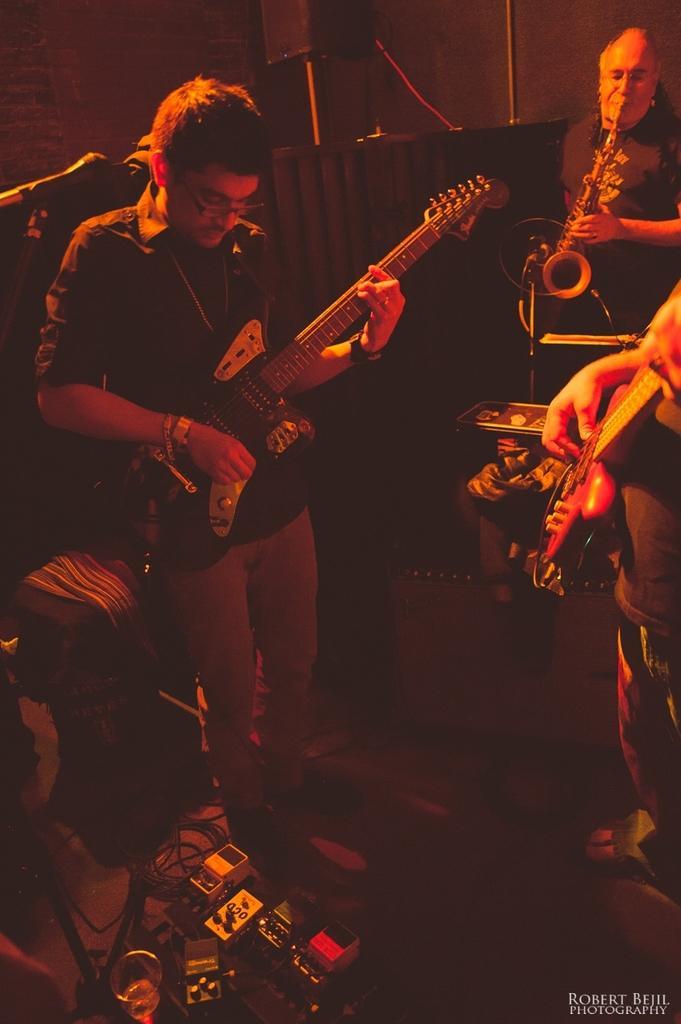Describe this image in one or two sentences. In this image there is a person standing and playing guitar, there is an other person standing at right side of the image and playing guitar, the person standing at back side of the image and playing musical instrument. At the bottom there are devices and wires. At the back there is a speaker. 